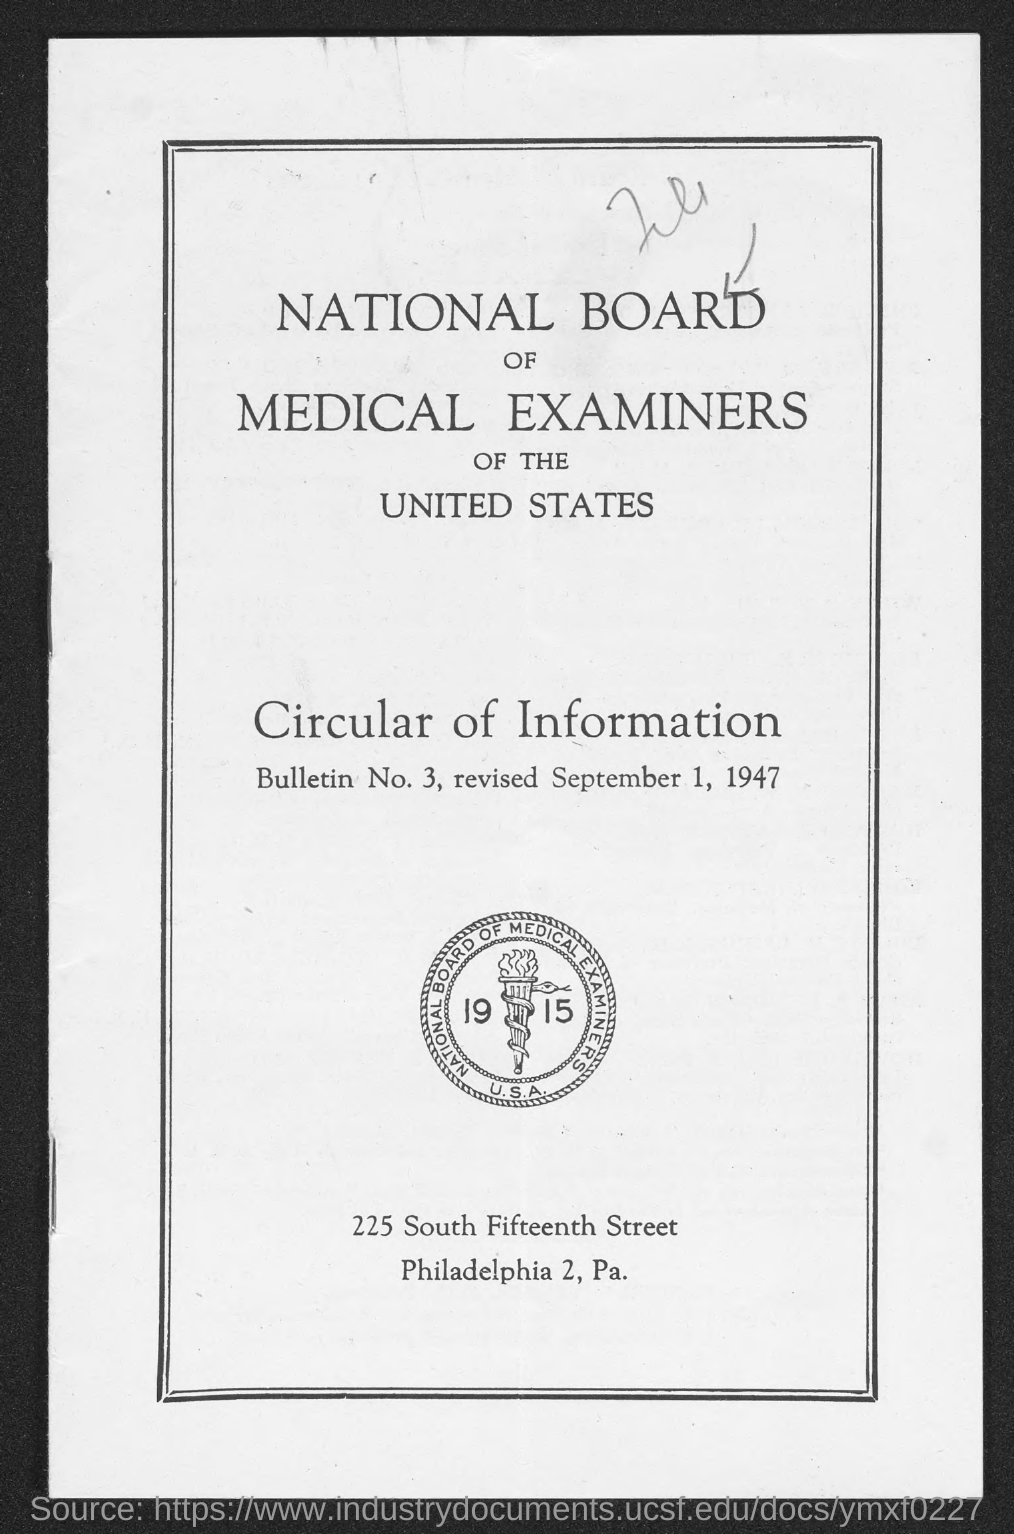What is the board mentioned in the given page ?
Give a very brief answer. National board of medical examiners of the united states. What is the bulletin no. mentioned in the given page ?
Your answer should be very brief. 3. What is the revised date mentioned in the given page ?
Your answer should be very brief. September 1, 1947. 